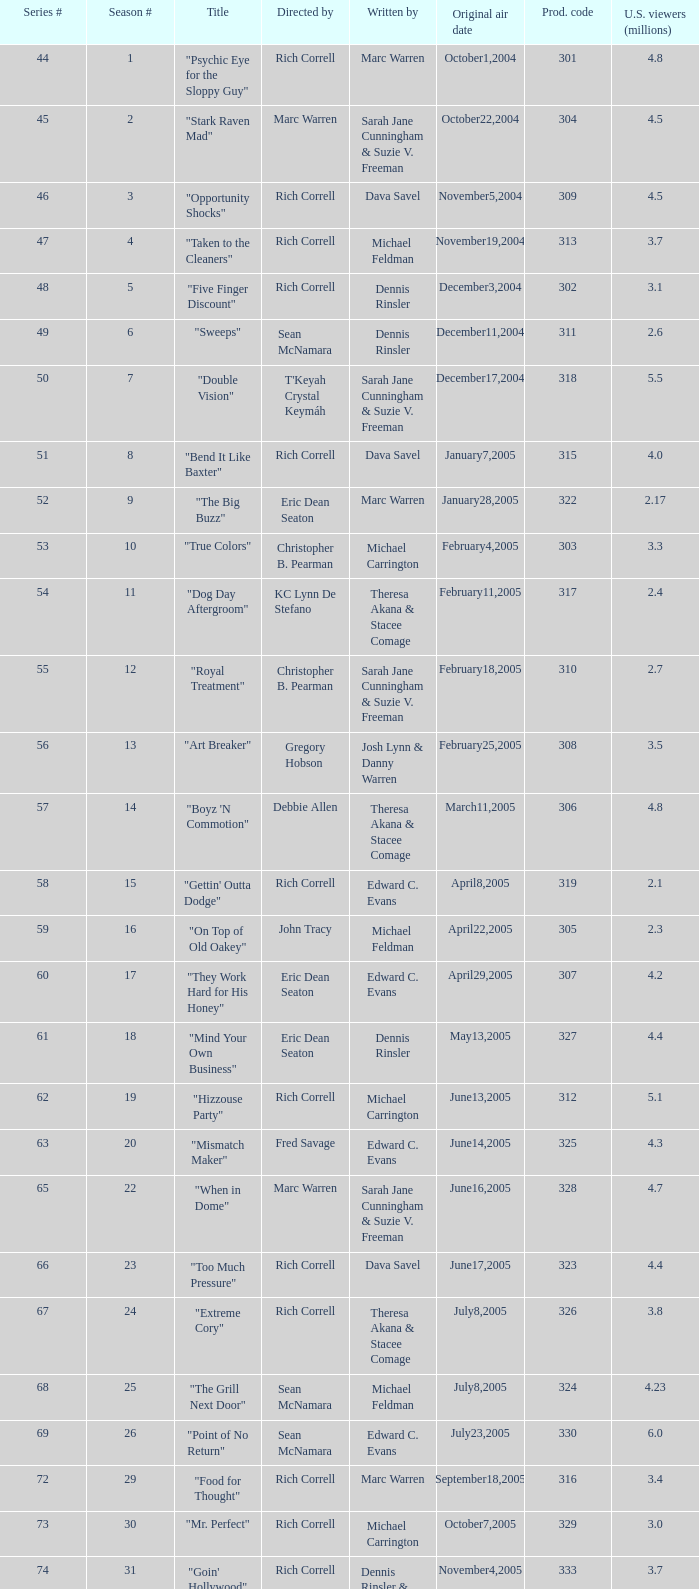What was the production code of the episode directed by Rondell Sheridan?  332.0. 